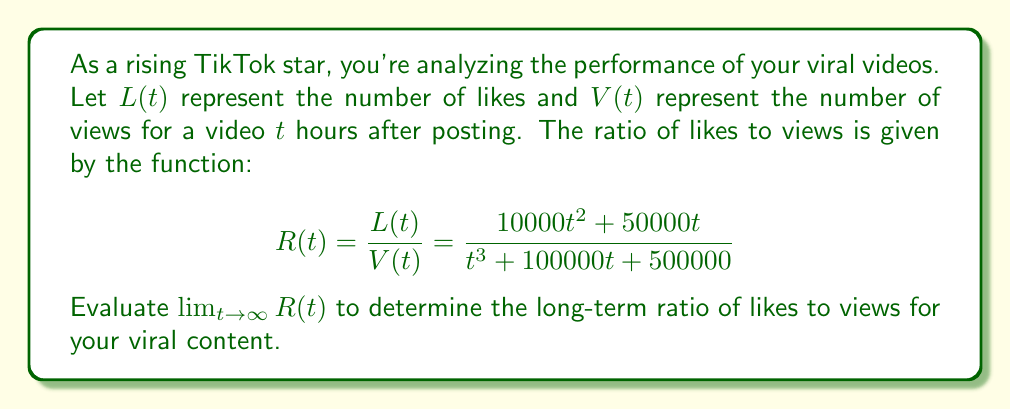Solve this math problem. To evaluate this limit, we'll follow these steps:

1) First, observe that both the numerator and denominator are polynomial functions. As $t$ approaches infinity, the highest degree term in each will dominate.

2) In the numerator, the highest degree term is $10000t^2$.
   In the denominator, the highest degree term is $t^3$.

3) We can factor out the highest power of $t$ from both numerator and denominator:

   $$\lim_{t \to \infty} \frac{10000t^2 + 50000t}{t^3 + 100000t + 500000}$$
   $$= \lim_{t \to \infty} \frac{t^2(10000 + \frac{50000}{t})}{t^3(1 + \frac{100000}{t^2} + \frac{500000}{t^3})}$$

4) Simplify:
   $$= \lim_{t \to \infty} \frac{10000 + \frac{50000}{t}}{t(1 + \frac{100000}{t^2} + \frac{500000}{t^3})}$$

5) As $t$ approaches infinity, $\frac{50000}{t}$, $\frac{100000}{t^2}$, and $\frac{500000}{t^3}$ all approach 0:

   $$= \lim_{t \to \infty} \frac{10000}{t(1)}$$

6) Simplify:
   $$= \lim_{t \to \infty} \frac{10000}{t} = 0$$

Therefore, as time approaches infinity, the ratio of likes to views approaches 0.
Answer: $0$ 